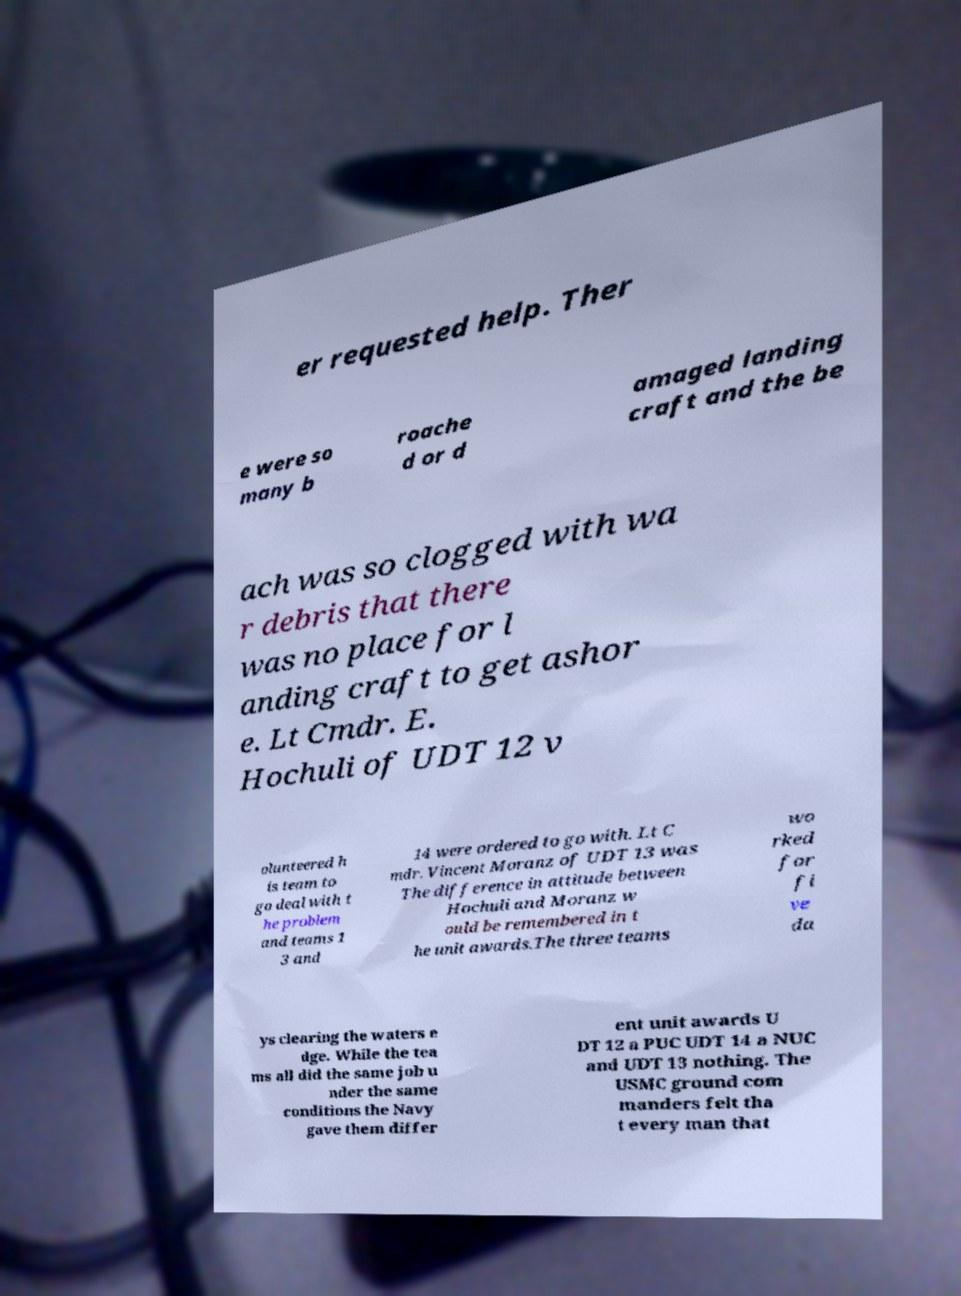Could you extract and type out the text from this image? er requested help. Ther e were so many b roache d or d amaged landing craft and the be ach was so clogged with wa r debris that there was no place for l anding craft to get ashor e. Lt Cmdr. E. Hochuli of UDT 12 v olunteered h is team to go deal with t he problem and teams 1 3 and 14 were ordered to go with. Lt C mdr. Vincent Moranz of UDT 13 was The difference in attitude between Hochuli and Moranz w ould be remembered in t he unit awards.The three teams wo rked for fi ve da ys clearing the waters e dge. While the tea ms all did the same job u nder the same conditions the Navy gave them differ ent unit awards U DT 12 a PUC UDT 14 a NUC and UDT 13 nothing. The USMC ground com manders felt tha t every man that 